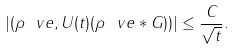Convert formula to latex. <formula><loc_0><loc_0><loc_500><loc_500>| ( \rho ^ { \ } v e , U ( t ) ( \rho ^ { \ } v e * G ) ) | \leq \frac { C } { \sqrt { t } } .</formula> 